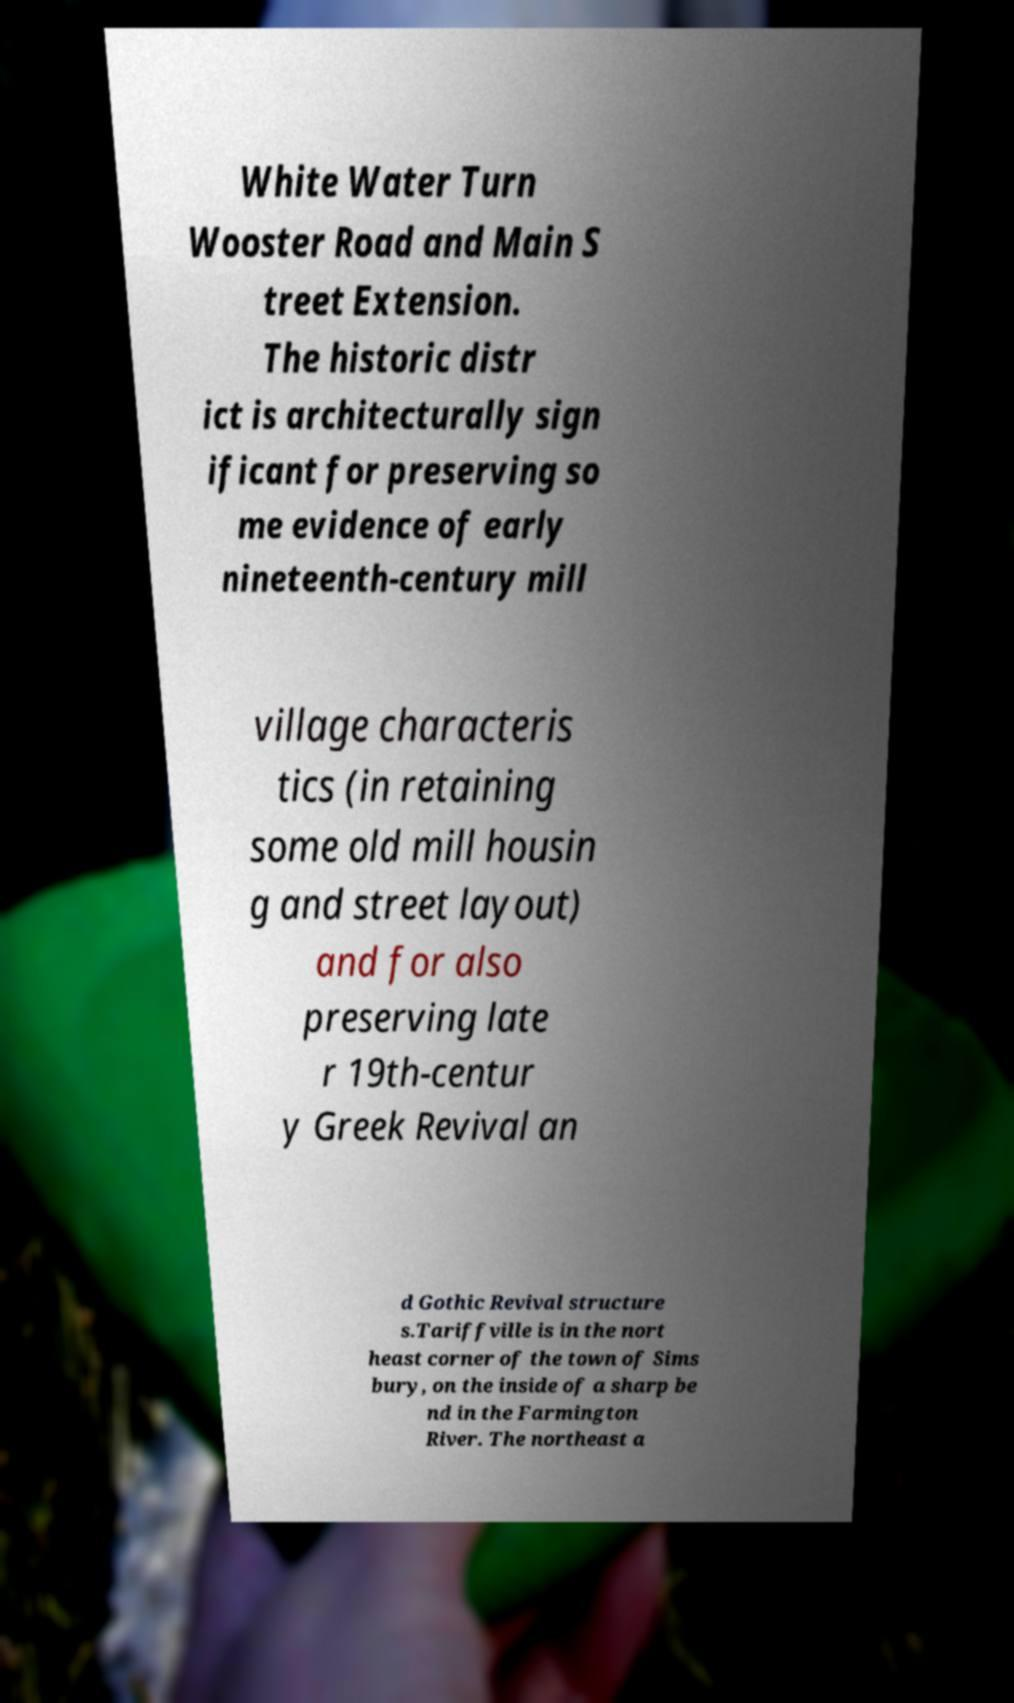Can you accurately transcribe the text from the provided image for me? White Water Turn Wooster Road and Main S treet Extension. The historic distr ict is architecturally sign ificant for preserving so me evidence of early nineteenth-century mill village characteris tics (in retaining some old mill housin g and street layout) and for also preserving late r 19th-centur y Greek Revival an d Gothic Revival structure s.Tariffville is in the nort heast corner of the town of Sims bury, on the inside of a sharp be nd in the Farmington River. The northeast a 